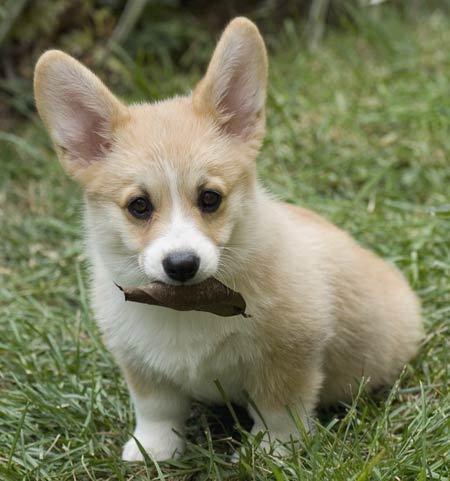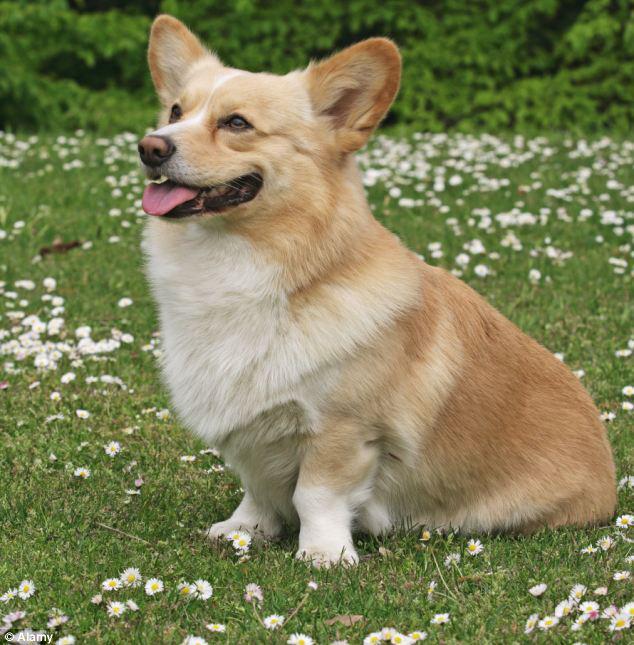The first image is the image on the left, the second image is the image on the right. Given the left and right images, does the statement "At least one dog is sitting on its hind legs in the pair of images." hold true? Answer yes or no. Yes. The first image is the image on the left, the second image is the image on the right. Evaluate the accuracy of this statement regarding the images: "Each image contains exactly one corgi dog, and no dog has its rear-end facing the camera.". Is it true? Answer yes or no. Yes. 